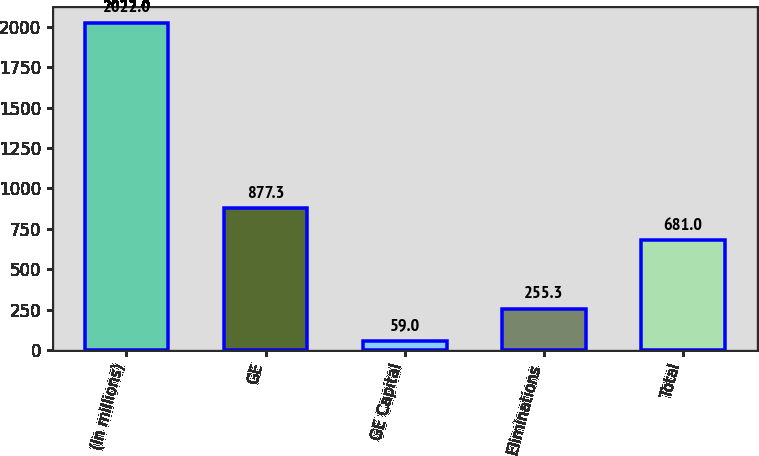Convert chart. <chart><loc_0><loc_0><loc_500><loc_500><bar_chart><fcel>(In millions)<fcel>GE<fcel>GE Capital<fcel>Eliminations<fcel>Total<nl><fcel>2022<fcel>877.3<fcel>59<fcel>255.3<fcel>681<nl></chart> 